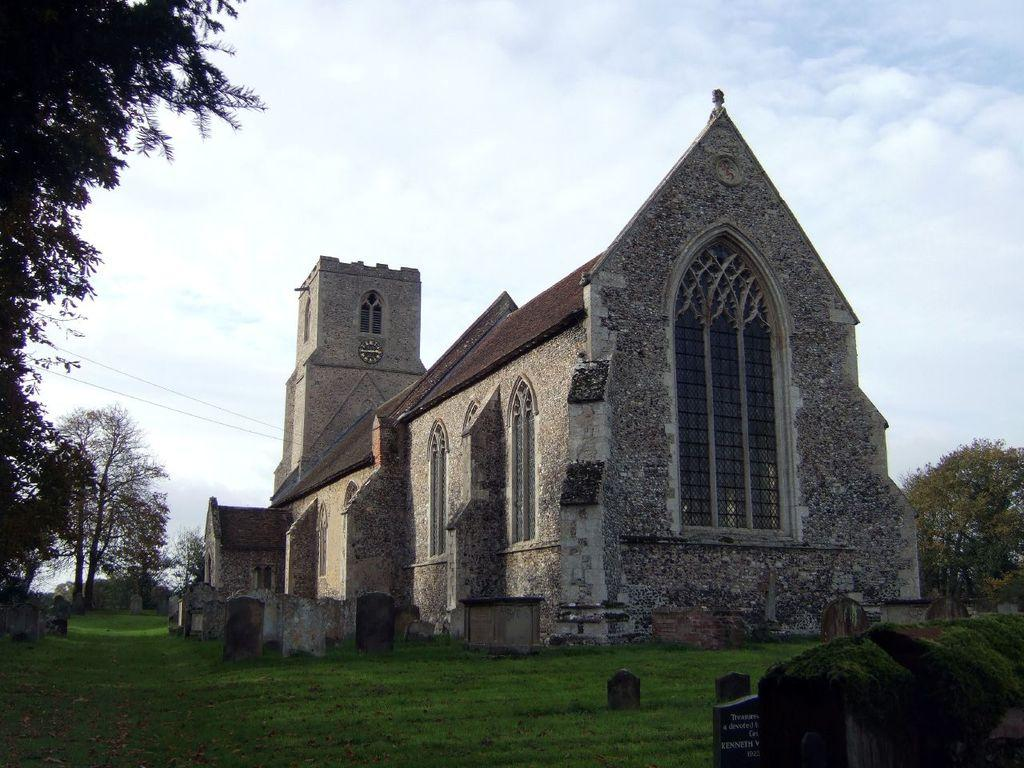What is the main structure in the image? There is a monument in the image. What type of vegetation can be seen in the image? There are trees visible in the image. What is visible in the sky in the image? The sky with clouds is visible at the top of the image. What type of ground surface is present at the bottom of the image? Grass is present at the bottom of the image. Where is the parcel being delivered in the image? There is no parcel present in the image. What type of bait is being used to catch fish in the image? There is no fishing or bait present in the image. 